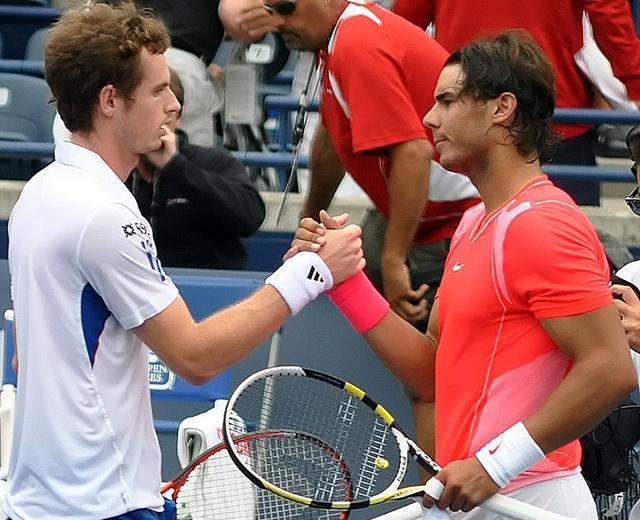How many people are in the picture?
Give a very brief answer. 7. How many chairs can be seen?
Give a very brief answer. 2. 